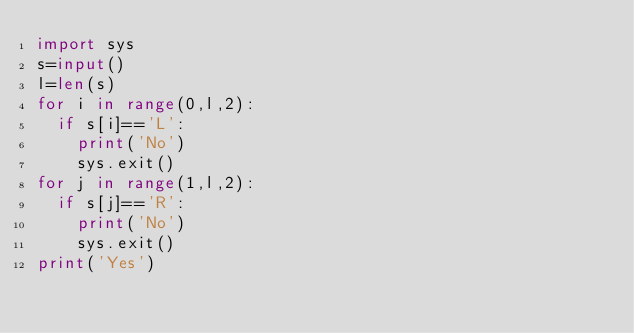<code> <loc_0><loc_0><loc_500><loc_500><_Python_>import sys
s=input()
l=len(s)
for i in range(0,l,2):
  if s[i]=='L':
    print('No')
    sys.exit()
for j in range(1,l,2):
  if s[j]=='R':
    print('No')
    sys.exit()
print('Yes')
</code> 